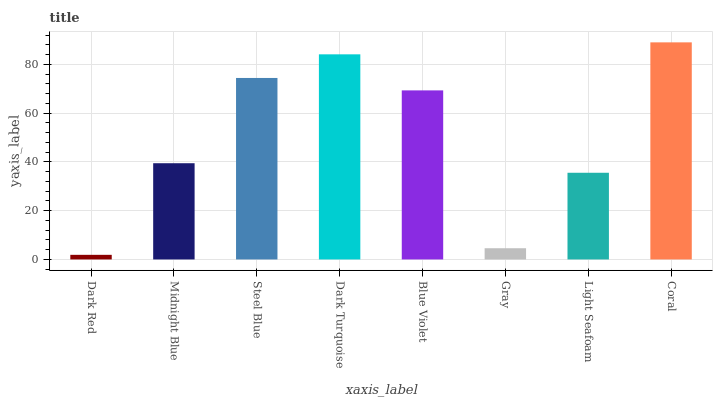Is Dark Red the minimum?
Answer yes or no. Yes. Is Coral the maximum?
Answer yes or no. Yes. Is Midnight Blue the minimum?
Answer yes or no. No. Is Midnight Blue the maximum?
Answer yes or no. No. Is Midnight Blue greater than Dark Red?
Answer yes or no. Yes. Is Dark Red less than Midnight Blue?
Answer yes or no. Yes. Is Dark Red greater than Midnight Blue?
Answer yes or no. No. Is Midnight Blue less than Dark Red?
Answer yes or no. No. Is Blue Violet the high median?
Answer yes or no. Yes. Is Midnight Blue the low median?
Answer yes or no. Yes. Is Midnight Blue the high median?
Answer yes or no. No. Is Gray the low median?
Answer yes or no. No. 